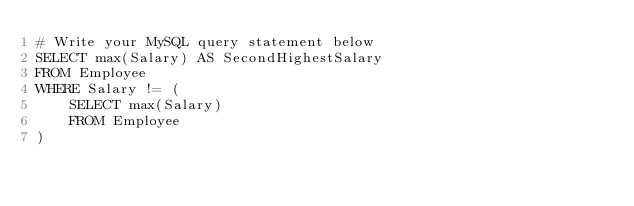<code> <loc_0><loc_0><loc_500><loc_500><_SQL_># Write your MySQL query statement below
SELECT max(Salary) AS SecondHighestSalary
FROM Employee
WHERE Salary != (
    SELECT max(Salary)
    FROM Employee
)
</code> 